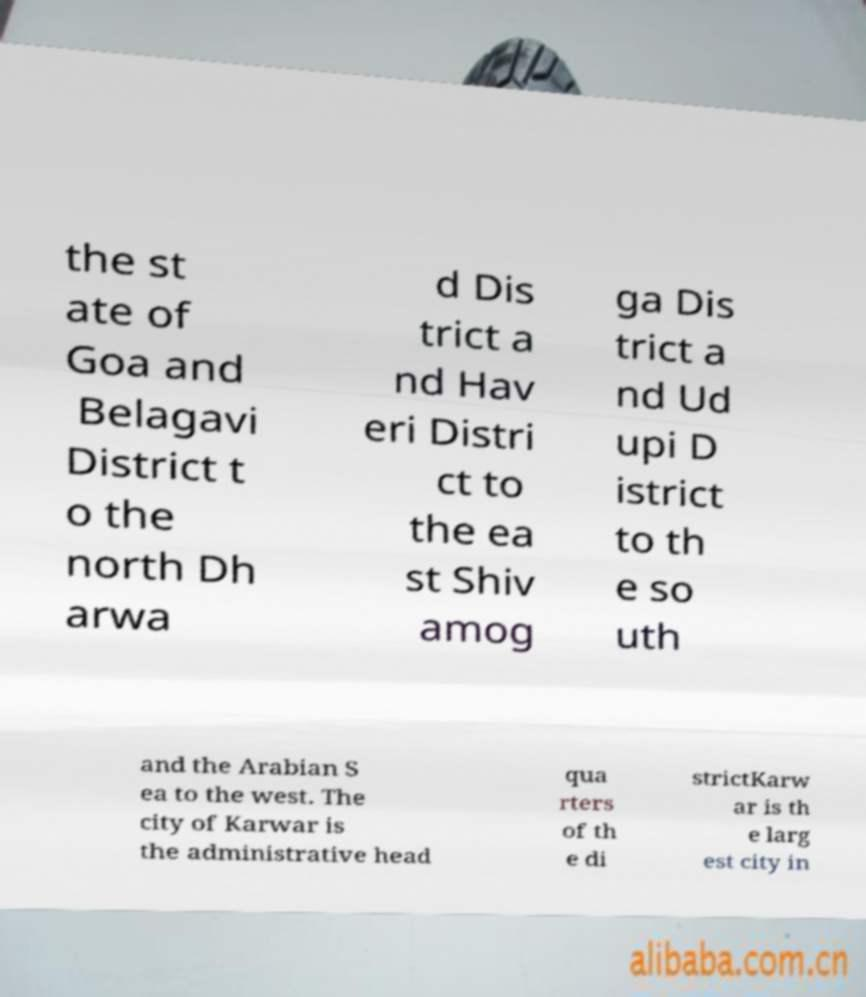Can you read and provide the text displayed in the image?This photo seems to have some interesting text. Can you extract and type it out for me? the st ate of Goa and Belagavi District t o the north Dh arwa d Dis trict a nd Hav eri Distri ct to the ea st Shiv amog ga Dis trict a nd Ud upi D istrict to th e so uth and the Arabian S ea to the west. The city of Karwar is the administrative head qua rters of th e di strictKarw ar is th e larg est city in 